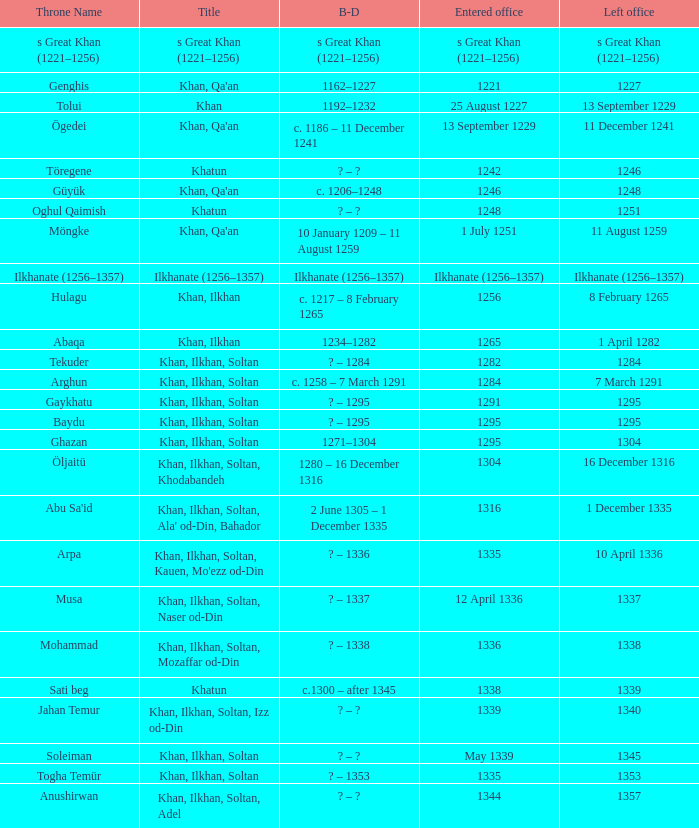What is the born-died that has office of 13 September 1229 as the entered? C. 1186 – 11 december 1241. 